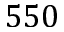Convert formula to latex. <formula><loc_0><loc_0><loc_500><loc_500>5 5 0</formula> 